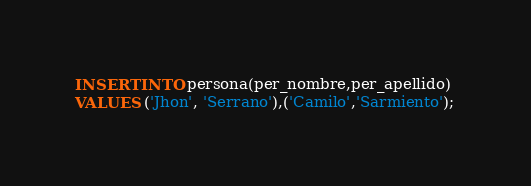Convert code to text. <code><loc_0><loc_0><loc_500><loc_500><_SQL_>INSERT INTO persona(per_nombre,per_apellido) 
VALUES ('Jhon', 'Serrano'),('Camilo','Sarmiento');</code> 